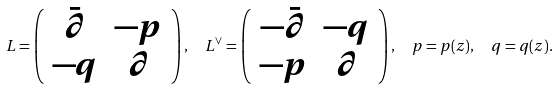<formula> <loc_0><loc_0><loc_500><loc_500>L = \left ( \begin{array} { c c } \bar { \partial } & - p \\ - q & \partial \end{array} \right ) , \ \ L ^ { \vee } = \left ( \begin{array} { c c } - \bar { \partial } & - q \\ - p & \partial \end{array} \right ) , \ \ p = p ( z ) , \ \ q = q ( z ) .</formula> 